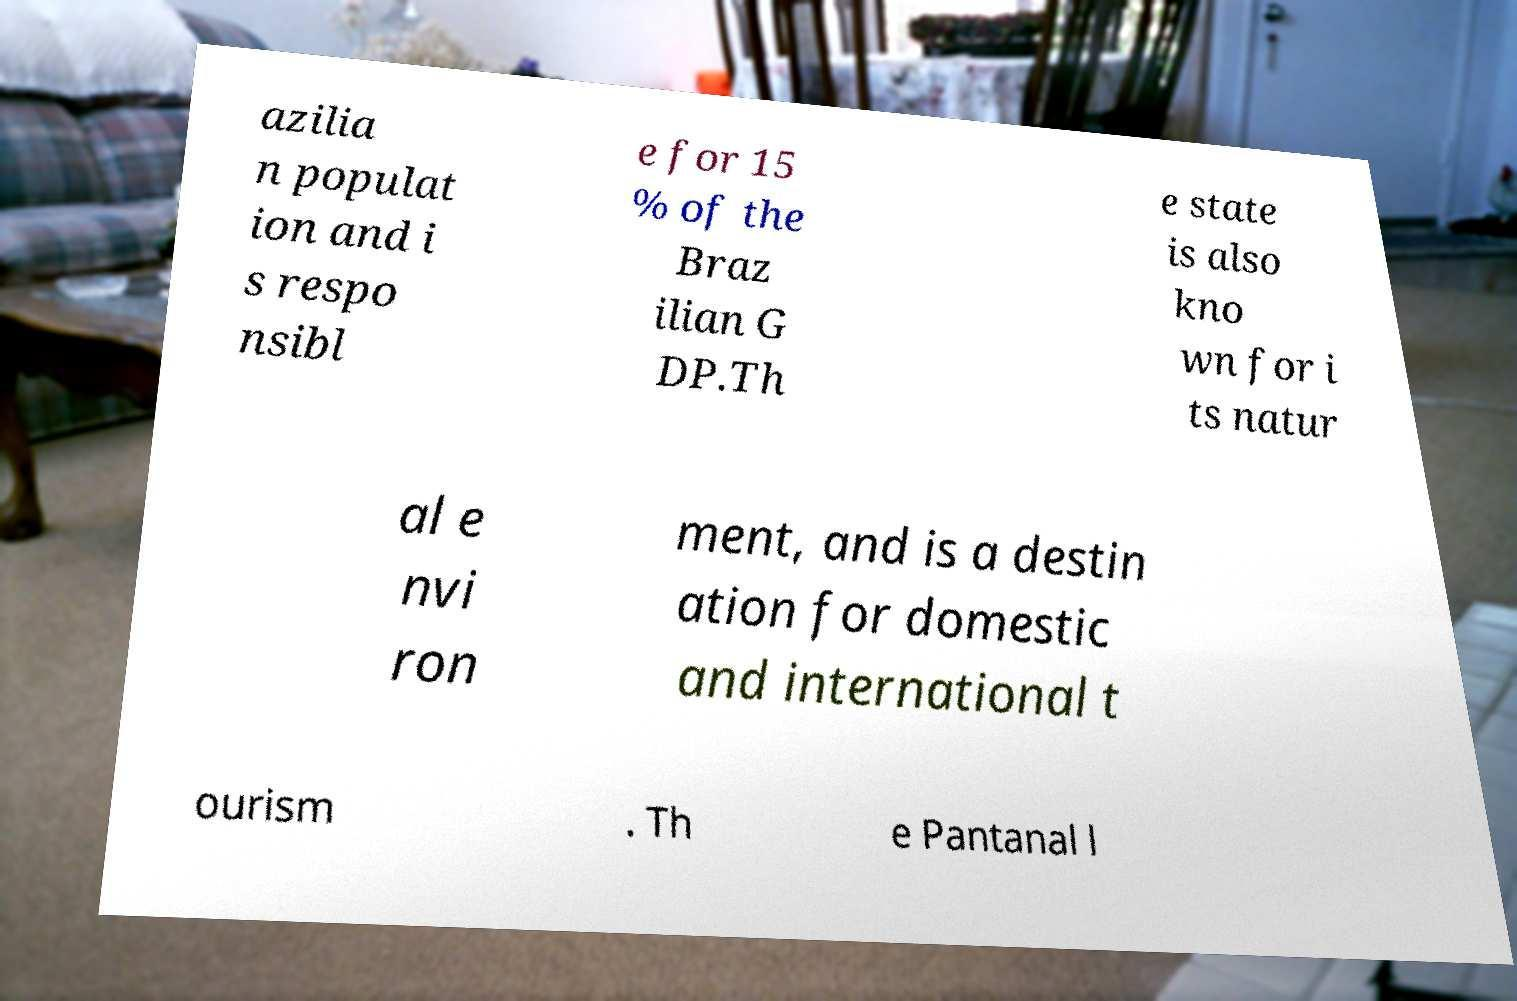For documentation purposes, I need the text within this image transcribed. Could you provide that? azilia n populat ion and i s respo nsibl e for 15 % of the Braz ilian G DP.Th e state is also kno wn for i ts natur al e nvi ron ment, and is a destin ation for domestic and international t ourism . Th e Pantanal l 